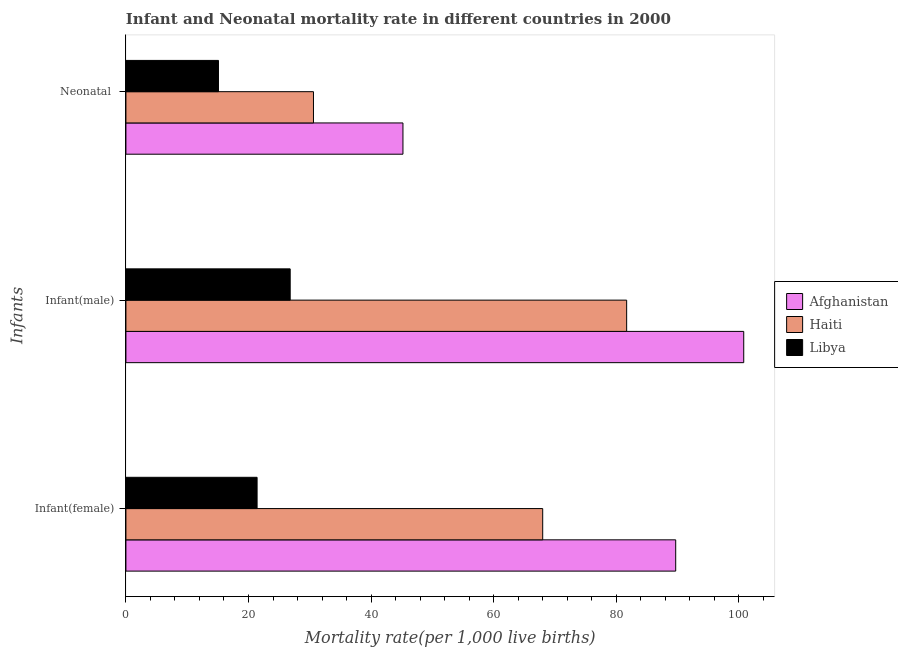How many groups of bars are there?
Give a very brief answer. 3. Are the number of bars per tick equal to the number of legend labels?
Your answer should be very brief. Yes. How many bars are there on the 3rd tick from the top?
Your answer should be very brief. 3. What is the label of the 2nd group of bars from the top?
Your answer should be very brief. Infant(male). What is the infant mortality rate(male) in Libya?
Your answer should be very brief. 26.8. Across all countries, what is the maximum infant mortality rate(male)?
Your answer should be very brief. 100.8. Across all countries, what is the minimum infant mortality rate(female)?
Offer a terse response. 21.4. In which country was the infant mortality rate(male) maximum?
Your answer should be compact. Afghanistan. In which country was the neonatal mortality rate minimum?
Make the answer very short. Libya. What is the total neonatal mortality rate in the graph?
Your answer should be compact. 90.9. What is the difference between the infant mortality rate(female) in Afghanistan and that in Haiti?
Offer a very short reply. 21.7. What is the difference between the infant mortality rate(female) in Libya and the infant mortality rate(male) in Afghanistan?
Your answer should be very brief. -79.4. What is the average infant mortality rate(male) per country?
Ensure brevity in your answer.  69.77. What is the difference between the infant mortality rate(female) and infant mortality rate(male) in Haiti?
Give a very brief answer. -13.7. What is the ratio of the infant mortality rate(female) in Afghanistan to that in Libya?
Keep it short and to the point. 4.19. Is the infant mortality rate(male) in Haiti less than that in Libya?
Ensure brevity in your answer.  No. What is the difference between the highest and the second highest neonatal mortality rate?
Your response must be concise. 14.6. In how many countries, is the infant mortality rate(female) greater than the average infant mortality rate(female) taken over all countries?
Provide a short and direct response. 2. Is the sum of the infant mortality rate(female) in Afghanistan and Libya greater than the maximum infant mortality rate(male) across all countries?
Your response must be concise. Yes. What does the 3rd bar from the top in Neonatal  represents?
Provide a succinct answer. Afghanistan. What does the 1st bar from the bottom in Neonatal  represents?
Offer a terse response. Afghanistan. Is it the case that in every country, the sum of the infant mortality rate(female) and infant mortality rate(male) is greater than the neonatal mortality rate?
Keep it short and to the point. Yes. Are the values on the major ticks of X-axis written in scientific E-notation?
Provide a short and direct response. No. Does the graph contain any zero values?
Give a very brief answer. No. Does the graph contain grids?
Give a very brief answer. No. Where does the legend appear in the graph?
Your response must be concise. Center right. What is the title of the graph?
Offer a very short reply. Infant and Neonatal mortality rate in different countries in 2000. Does "Middle East & North Africa (developing only)" appear as one of the legend labels in the graph?
Keep it short and to the point. No. What is the label or title of the X-axis?
Offer a terse response. Mortality rate(per 1,0 live births). What is the label or title of the Y-axis?
Your answer should be very brief. Infants. What is the Mortality rate(per 1,000 live births) of Afghanistan in Infant(female)?
Your answer should be very brief. 89.7. What is the Mortality rate(per 1,000 live births) of Libya in Infant(female)?
Give a very brief answer. 21.4. What is the Mortality rate(per 1,000 live births) in Afghanistan in Infant(male)?
Make the answer very short. 100.8. What is the Mortality rate(per 1,000 live births) in Haiti in Infant(male)?
Provide a short and direct response. 81.7. What is the Mortality rate(per 1,000 live births) of Libya in Infant(male)?
Your answer should be compact. 26.8. What is the Mortality rate(per 1,000 live births) of Afghanistan in Neonatal ?
Your answer should be very brief. 45.2. What is the Mortality rate(per 1,000 live births) of Haiti in Neonatal ?
Your answer should be very brief. 30.6. Across all Infants, what is the maximum Mortality rate(per 1,000 live births) of Afghanistan?
Make the answer very short. 100.8. Across all Infants, what is the maximum Mortality rate(per 1,000 live births) in Haiti?
Your answer should be very brief. 81.7. Across all Infants, what is the maximum Mortality rate(per 1,000 live births) in Libya?
Make the answer very short. 26.8. Across all Infants, what is the minimum Mortality rate(per 1,000 live births) of Afghanistan?
Your answer should be very brief. 45.2. Across all Infants, what is the minimum Mortality rate(per 1,000 live births) in Haiti?
Your answer should be very brief. 30.6. What is the total Mortality rate(per 1,000 live births) of Afghanistan in the graph?
Keep it short and to the point. 235.7. What is the total Mortality rate(per 1,000 live births) of Haiti in the graph?
Offer a terse response. 180.3. What is the total Mortality rate(per 1,000 live births) in Libya in the graph?
Provide a short and direct response. 63.3. What is the difference between the Mortality rate(per 1,000 live births) of Afghanistan in Infant(female) and that in Infant(male)?
Keep it short and to the point. -11.1. What is the difference between the Mortality rate(per 1,000 live births) of Haiti in Infant(female) and that in Infant(male)?
Make the answer very short. -13.7. What is the difference between the Mortality rate(per 1,000 live births) of Libya in Infant(female) and that in Infant(male)?
Your answer should be compact. -5.4. What is the difference between the Mortality rate(per 1,000 live births) in Afghanistan in Infant(female) and that in Neonatal ?
Provide a short and direct response. 44.5. What is the difference between the Mortality rate(per 1,000 live births) in Haiti in Infant(female) and that in Neonatal ?
Keep it short and to the point. 37.4. What is the difference between the Mortality rate(per 1,000 live births) in Libya in Infant(female) and that in Neonatal ?
Give a very brief answer. 6.3. What is the difference between the Mortality rate(per 1,000 live births) in Afghanistan in Infant(male) and that in Neonatal ?
Give a very brief answer. 55.6. What is the difference between the Mortality rate(per 1,000 live births) in Haiti in Infant(male) and that in Neonatal ?
Your answer should be compact. 51.1. What is the difference between the Mortality rate(per 1,000 live births) of Afghanistan in Infant(female) and the Mortality rate(per 1,000 live births) of Haiti in Infant(male)?
Keep it short and to the point. 8. What is the difference between the Mortality rate(per 1,000 live births) in Afghanistan in Infant(female) and the Mortality rate(per 1,000 live births) in Libya in Infant(male)?
Your answer should be compact. 62.9. What is the difference between the Mortality rate(per 1,000 live births) of Haiti in Infant(female) and the Mortality rate(per 1,000 live births) of Libya in Infant(male)?
Your response must be concise. 41.2. What is the difference between the Mortality rate(per 1,000 live births) of Afghanistan in Infant(female) and the Mortality rate(per 1,000 live births) of Haiti in Neonatal ?
Offer a terse response. 59.1. What is the difference between the Mortality rate(per 1,000 live births) of Afghanistan in Infant(female) and the Mortality rate(per 1,000 live births) of Libya in Neonatal ?
Make the answer very short. 74.6. What is the difference between the Mortality rate(per 1,000 live births) of Haiti in Infant(female) and the Mortality rate(per 1,000 live births) of Libya in Neonatal ?
Offer a terse response. 52.9. What is the difference between the Mortality rate(per 1,000 live births) of Afghanistan in Infant(male) and the Mortality rate(per 1,000 live births) of Haiti in Neonatal ?
Make the answer very short. 70.2. What is the difference between the Mortality rate(per 1,000 live births) in Afghanistan in Infant(male) and the Mortality rate(per 1,000 live births) in Libya in Neonatal ?
Offer a very short reply. 85.7. What is the difference between the Mortality rate(per 1,000 live births) in Haiti in Infant(male) and the Mortality rate(per 1,000 live births) in Libya in Neonatal ?
Offer a terse response. 66.6. What is the average Mortality rate(per 1,000 live births) in Afghanistan per Infants?
Make the answer very short. 78.57. What is the average Mortality rate(per 1,000 live births) of Haiti per Infants?
Keep it short and to the point. 60.1. What is the average Mortality rate(per 1,000 live births) in Libya per Infants?
Ensure brevity in your answer.  21.1. What is the difference between the Mortality rate(per 1,000 live births) in Afghanistan and Mortality rate(per 1,000 live births) in Haiti in Infant(female)?
Provide a succinct answer. 21.7. What is the difference between the Mortality rate(per 1,000 live births) in Afghanistan and Mortality rate(per 1,000 live births) in Libya in Infant(female)?
Give a very brief answer. 68.3. What is the difference between the Mortality rate(per 1,000 live births) of Haiti and Mortality rate(per 1,000 live births) of Libya in Infant(female)?
Give a very brief answer. 46.6. What is the difference between the Mortality rate(per 1,000 live births) in Afghanistan and Mortality rate(per 1,000 live births) in Haiti in Infant(male)?
Provide a short and direct response. 19.1. What is the difference between the Mortality rate(per 1,000 live births) in Afghanistan and Mortality rate(per 1,000 live births) in Libya in Infant(male)?
Your response must be concise. 74. What is the difference between the Mortality rate(per 1,000 live births) in Haiti and Mortality rate(per 1,000 live births) in Libya in Infant(male)?
Your answer should be very brief. 54.9. What is the difference between the Mortality rate(per 1,000 live births) of Afghanistan and Mortality rate(per 1,000 live births) of Haiti in Neonatal ?
Offer a very short reply. 14.6. What is the difference between the Mortality rate(per 1,000 live births) in Afghanistan and Mortality rate(per 1,000 live births) in Libya in Neonatal ?
Your answer should be very brief. 30.1. What is the difference between the Mortality rate(per 1,000 live births) of Haiti and Mortality rate(per 1,000 live births) of Libya in Neonatal ?
Make the answer very short. 15.5. What is the ratio of the Mortality rate(per 1,000 live births) in Afghanistan in Infant(female) to that in Infant(male)?
Make the answer very short. 0.89. What is the ratio of the Mortality rate(per 1,000 live births) of Haiti in Infant(female) to that in Infant(male)?
Ensure brevity in your answer.  0.83. What is the ratio of the Mortality rate(per 1,000 live births) in Libya in Infant(female) to that in Infant(male)?
Offer a very short reply. 0.8. What is the ratio of the Mortality rate(per 1,000 live births) of Afghanistan in Infant(female) to that in Neonatal ?
Give a very brief answer. 1.98. What is the ratio of the Mortality rate(per 1,000 live births) of Haiti in Infant(female) to that in Neonatal ?
Offer a very short reply. 2.22. What is the ratio of the Mortality rate(per 1,000 live births) in Libya in Infant(female) to that in Neonatal ?
Your answer should be compact. 1.42. What is the ratio of the Mortality rate(per 1,000 live births) of Afghanistan in Infant(male) to that in Neonatal ?
Make the answer very short. 2.23. What is the ratio of the Mortality rate(per 1,000 live births) in Haiti in Infant(male) to that in Neonatal ?
Ensure brevity in your answer.  2.67. What is the ratio of the Mortality rate(per 1,000 live births) in Libya in Infant(male) to that in Neonatal ?
Provide a succinct answer. 1.77. What is the difference between the highest and the second highest Mortality rate(per 1,000 live births) of Libya?
Make the answer very short. 5.4. What is the difference between the highest and the lowest Mortality rate(per 1,000 live births) in Afghanistan?
Offer a very short reply. 55.6. What is the difference between the highest and the lowest Mortality rate(per 1,000 live births) of Haiti?
Your answer should be very brief. 51.1. What is the difference between the highest and the lowest Mortality rate(per 1,000 live births) of Libya?
Offer a very short reply. 11.7. 